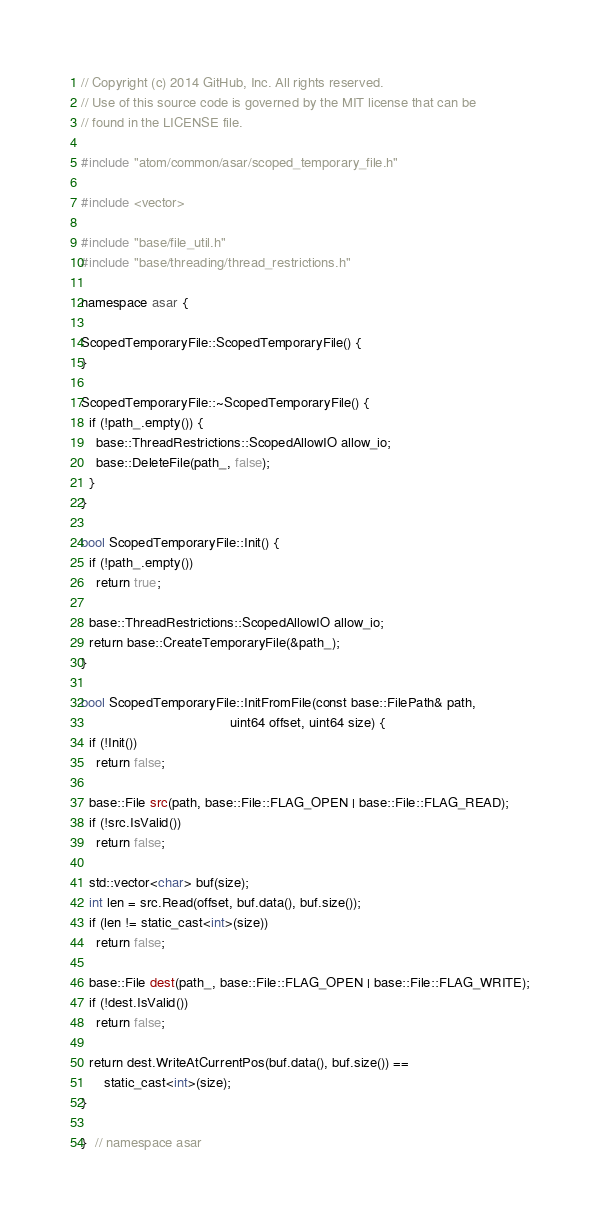Convert code to text. <code><loc_0><loc_0><loc_500><loc_500><_C++_>// Copyright (c) 2014 GitHub, Inc. All rights reserved.
// Use of this source code is governed by the MIT license that can be
// found in the LICENSE file.

#include "atom/common/asar/scoped_temporary_file.h"

#include <vector>

#include "base/file_util.h"
#include "base/threading/thread_restrictions.h"

namespace asar {

ScopedTemporaryFile::ScopedTemporaryFile() {
}

ScopedTemporaryFile::~ScopedTemporaryFile() {
  if (!path_.empty()) {
    base::ThreadRestrictions::ScopedAllowIO allow_io;
    base::DeleteFile(path_, false);
  }
}

bool ScopedTemporaryFile::Init() {
  if (!path_.empty())
    return true;

  base::ThreadRestrictions::ScopedAllowIO allow_io;
  return base::CreateTemporaryFile(&path_);
}

bool ScopedTemporaryFile::InitFromFile(const base::FilePath& path,
                                       uint64 offset, uint64 size) {
  if (!Init())
    return false;

  base::File src(path, base::File::FLAG_OPEN | base::File::FLAG_READ);
  if (!src.IsValid())
    return false;

  std::vector<char> buf(size);
  int len = src.Read(offset, buf.data(), buf.size());
  if (len != static_cast<int>(size))
    return false;

  base::File dest(path_, base::File::FLAG_OPEN | base::File::FLAG_WRITE);
  if (!dest.IsValid())
    return false;

  return dest.WriteAtCurrentPos(buf.data(), buf.size()) ==
      static_cast<int>(size);
}

}  // namespace asar
</code> 